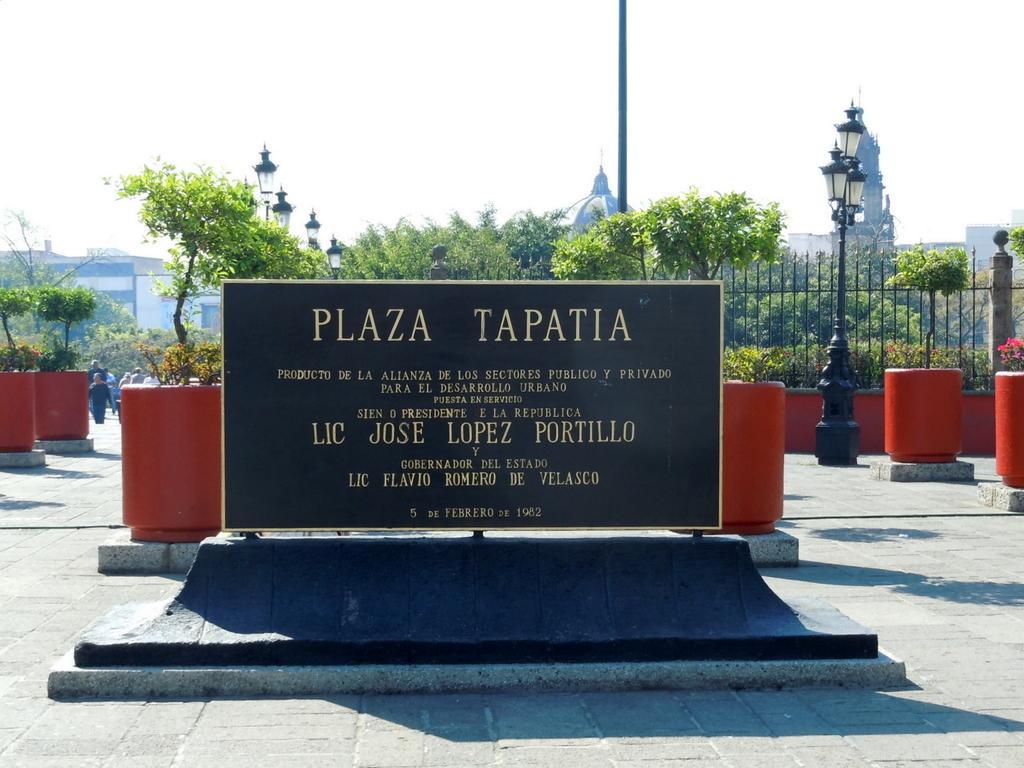In one or two sentences, can you explain what this image depicts? In the middle it is a sculptured, behind this there are trees. At the top it is the sky. 